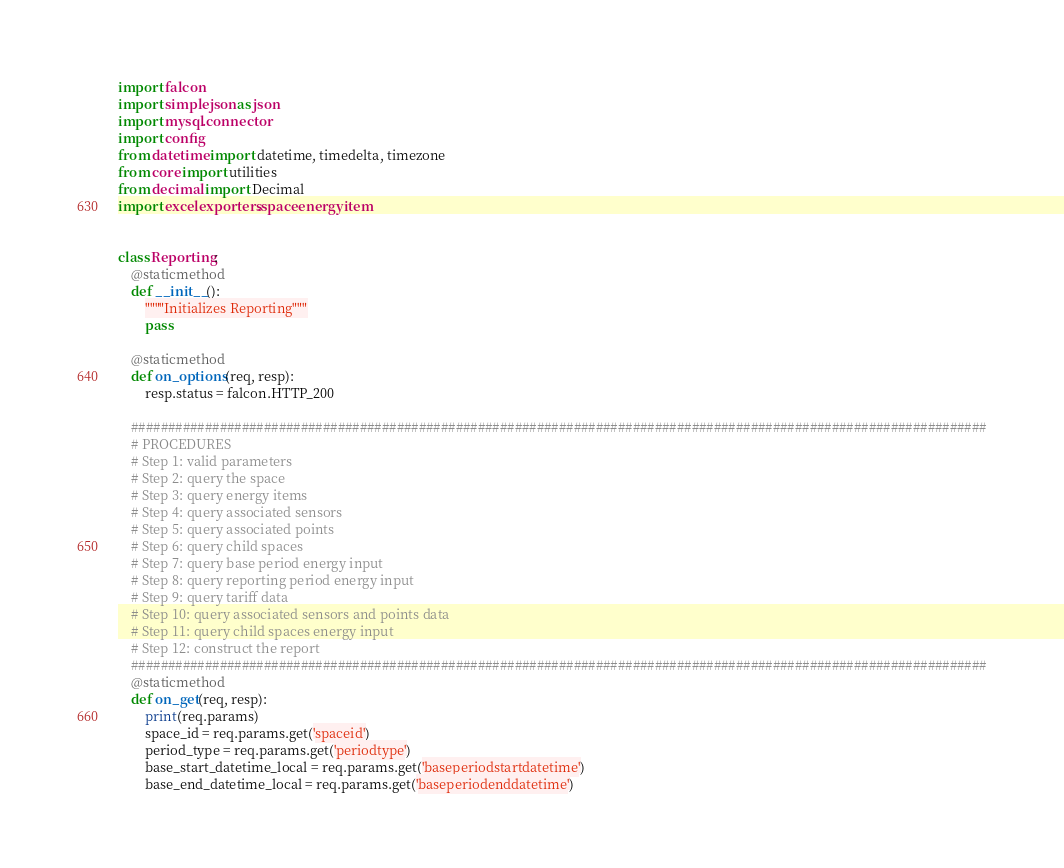<code> <loc_0><loc_0><loc_500><loc_500><_Python_>import falcon
import simplejson as json
import mysql.connector
import config
from datetime import datetime, timedelta, timezone
from core import utilities
from decimal import Decimal
import excelexporters.spaceenergyitem


class Reporting:
    @staticmethod
    def __init__():
        """"Initializes Reporting"""
        pass

    @staticmethod
    def on_options(req, resp):
        resp.status = falcon.HTTP_200

    ####################################################################################################################
    # PROCEDURES
    # Step 1: valid parameters
    # Step 2: query the space
    # Step 3: query energy items
    # Step 4: query associated sensors
    # Step 5: query associated points
    # Step 6: query child spaces
    # Step 7: query base period energy input
    # Step 8: query reporting period energy input
    # Step 9: query tariff data
    # Step 10: query associated sensors and points data
    # Step 11: query child spaces energy input
    # Step 12: construct the report
    ####################################################################################################################
    @staticmethod
    def on_get(req, resp):
        print(req.params)
        space_id = req.params.get('spaceid')
        period_type = req.params.get('periodtype')
        base_start_datetime_local = req.params.get('baseperiodstartdatetime')
        base_end_datetime_local = req.params.get('baseperiodenddatetime')</code> 